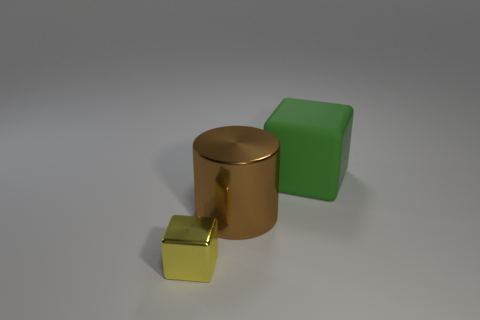The big thing in front of the green rubber cube has what shape? cylinder 